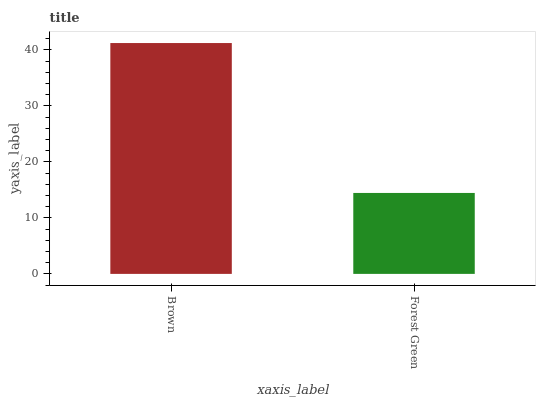Is Forest Green the minimum?
Answer yes or no. Yes. Is Brown the maximum?
Answer yes or no. Yes. Is Forest Green the maximum?
Answer yes or no. No. Is Brown greater than Forest Green?
Answer yes or no. Yes. Is Forest Green less than Brown?
Answer yes or no. Yes. Is Forest Green greater than Brown?
Answer yes or no. No. Is Brown less than Forest Green?
Answer yes or no. No. Is Brown the high median?
Answer yes or no. Yes. Is Forest Green the low median?
Answer yes or no. Yes. Is Forest Green the high median?
Answer yes or no. No. Is Brown the low median?
Answer yes or no. No. 